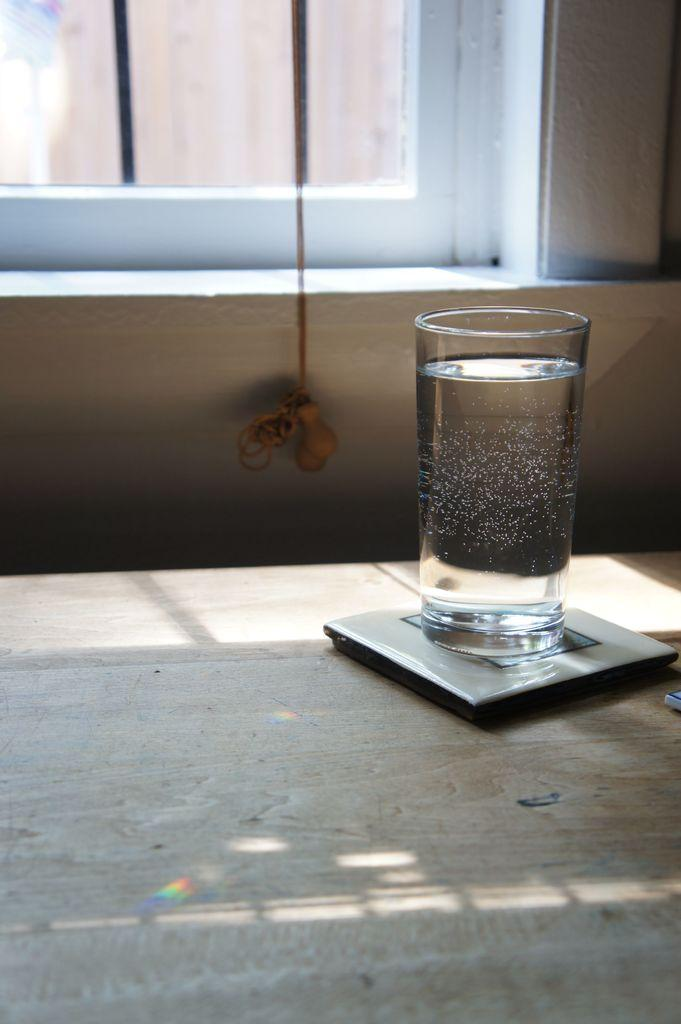What is in the glass that is visible in the image? The glass contains water. What is on the table that is visible in the image? There is a table mat and a glass of water on the table. What can be seen in the background of the image? There is a rope, a window, and a wall in the background of the image. How does the cactus expand in the image? There is no cactus present in the image, so it cannot expand. 